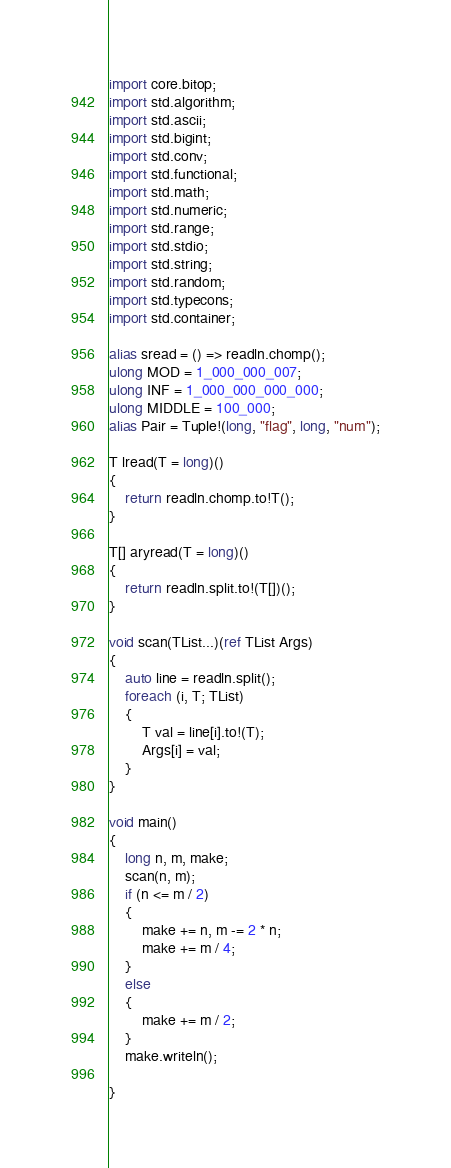Convert code to text. <code><loc_0><loc_0><loc_500><loc_500><_D_>import core.bitop;
import std.algorithm;
import std.ascii;
import std.bigint;
import std.conv;
import std.functional;
import std.math;
import std.numeric;
import std.range;
import std.stdio;
import std.string;
import std.random;
import std.typecons;
import std.container;

alias sread = () => readln.chomp();
ulong MOD = 1_000_000_007;
ulong INF = 1_000_000_000_000;
ulong MIDDLE = 100_000;
alias Pair = Tuple!(long, "flag", long, "num");

T lread(T = long)()
{
    return readln.chomp.to!T();
}

T[] aryread(T = long)()
{
    return readln.split.to!(T[])();
}

void scan(TList...)(ref TList Args)
{
    auto line = readln.split();
    foreach (i, T; TList)
    {
        T val = line[i].to!(T);
        Args[i] = val;
    }
}

void main()
{
    long n, m, make;
    scan(n, m);
    if (n <= m / 2)
    {
        make += n, m -= 2 * n;
        make += m / 4;
    }
    else
    {
        make += m / 2;
    }
    make.writeln();

}
</code> 